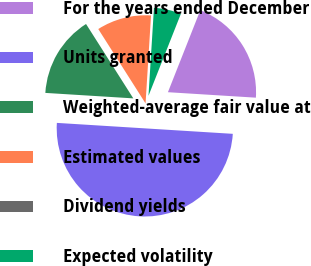Convert chart to OTSL. <chart><loc_0><loc_0><loc_500><loc_500><pie_chart><fcel>For the years ended December<fcel>Units granted<fcel>Weighted-average fair value at<fcel>Estimated values<fcel>Dividend yields<fcel>Expected volatility<nl><fcel>20.0%<fcel>50.0%<fcel>15.0%<fcel>10.0%<fcel>0.0%<fcel>5.0%<nl></chart> 